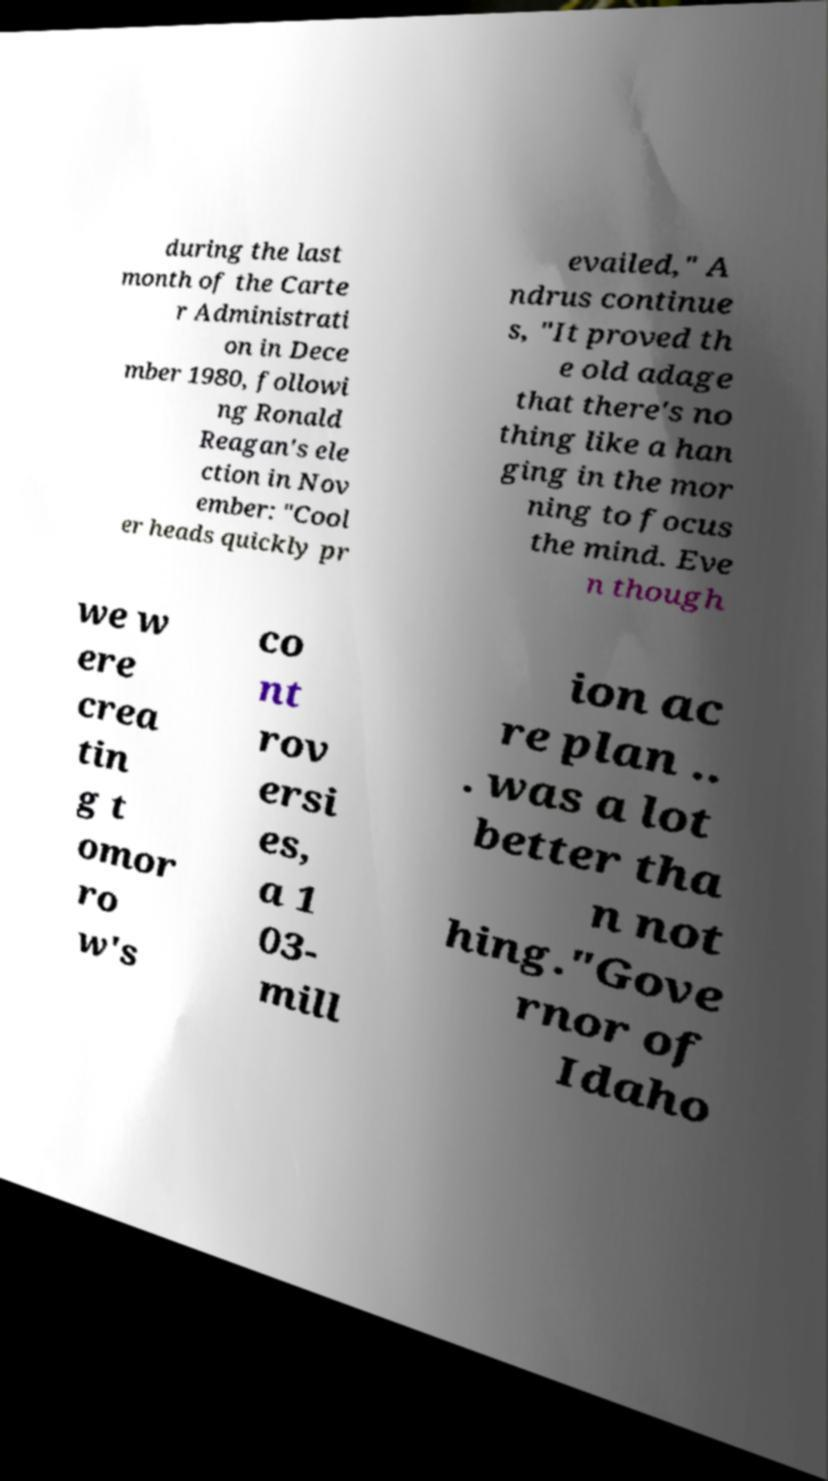There's text embedded in this image that I need extracted. Can you transcribe it verbatim? during the last month of the Carte r Administrati on in Dece mber 1980, followi ng Ronald Reagan's ele ction in Nov ember: "Cool er heads quickly pr evailed," A ndrus continue s, "It proved th e old adage that there's no thing like a han ging in the mor ning to focus the mind. Eve n though we w ere crea tin g t omor ro w's co nt rov ersi es, a 1 03- mill ion ac re plan .. . was a lot better tha n not hing."Gove rnor of Idaho 